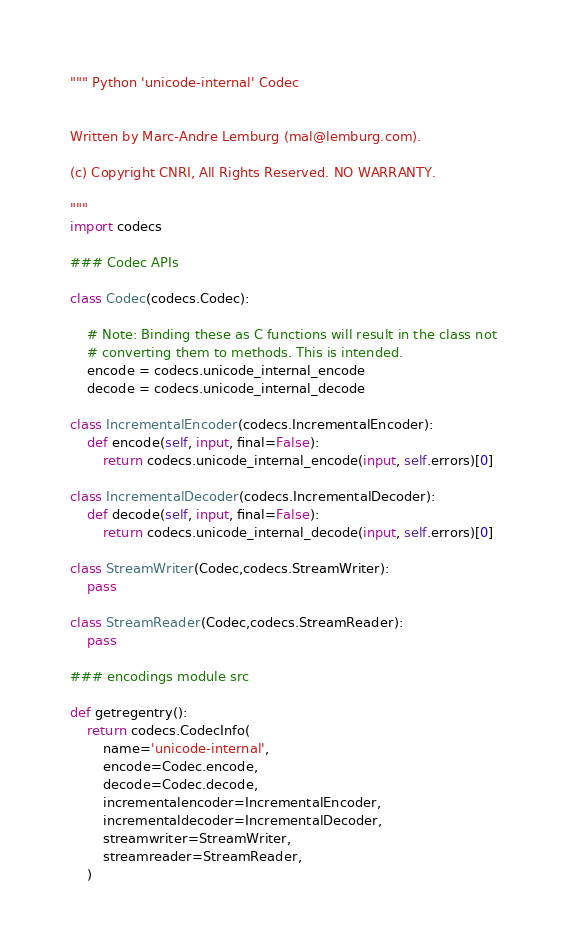<code> <loc_0><loc_0><loc_500><loc_500><_Python_>""" Python 'unicode-internal' Codec


Written by Marc-Andre Lemburg (mal@lemburg.com).

(c) Copyright CNRI, All Rights Reserved. NO WARRANTY.

"""
import codecs

### Codec APIs

class Codec(codecs.Codec):

    # Note: Binding these as C functions will result in the class not
    # converting them to methods. This is intended.
    encode = codecs.unicode_internal_encode
    decode = codecs.unicode_internal_decode

class IncrementalEncoder(codecs.IncrementalEncoder):
    def encode(self, input, final=False):
        return codecs.unicode_internal_encode(input, self.errors)[0]

class IncrementalDecoder(codecs.IncrementalDecoder):
    def decode(self, input, final=False):
        return codecs.unicode_internal_decode(input, self.errors)[0]

class StreamWriter(Codec,codecs.StreamWriter):
    pass

class StreamReader(Codec,codecs.StreamReader):
    pass

### encodings module src

def getregentry():
    return codecs.CodecInfo(
        name='unicode-internal',
        encode=Codec.encode,
        decode=Codec.decode,
        incrementalencoder=IncrementalEncoder,
        incrementaldecoder=IncrementalDecoder,
        streamwriter=StreamWriter,
        streamreader=StreamReader,
    )
</code> 